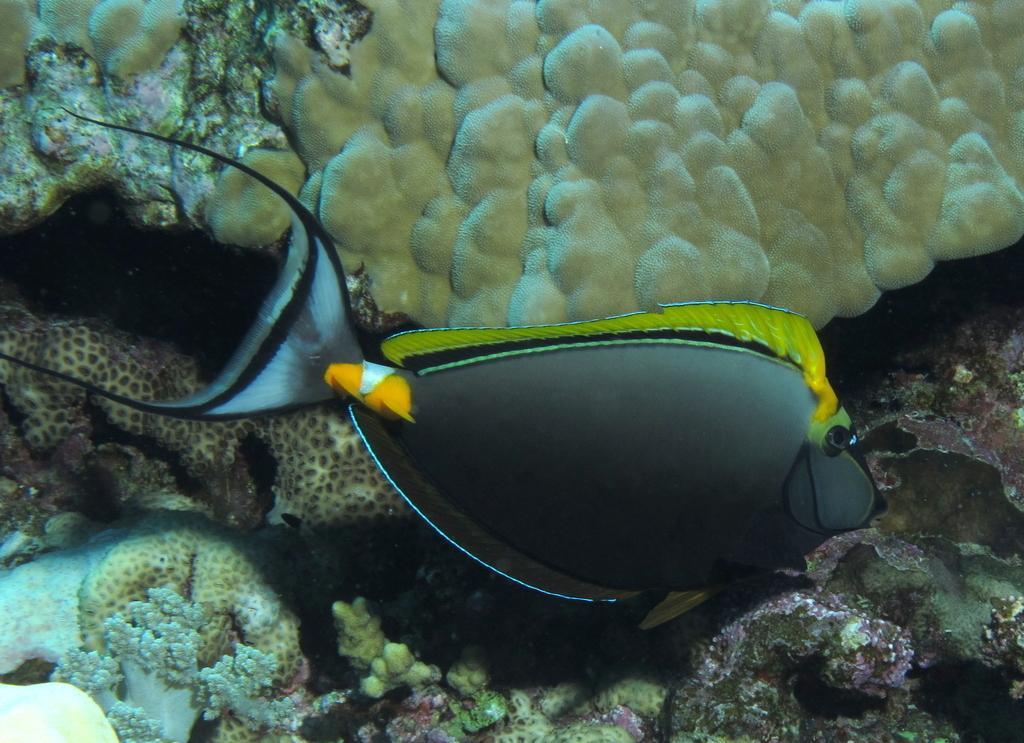Can you describe this image briefly? In this image we can see fish and coral reefs underwater. 